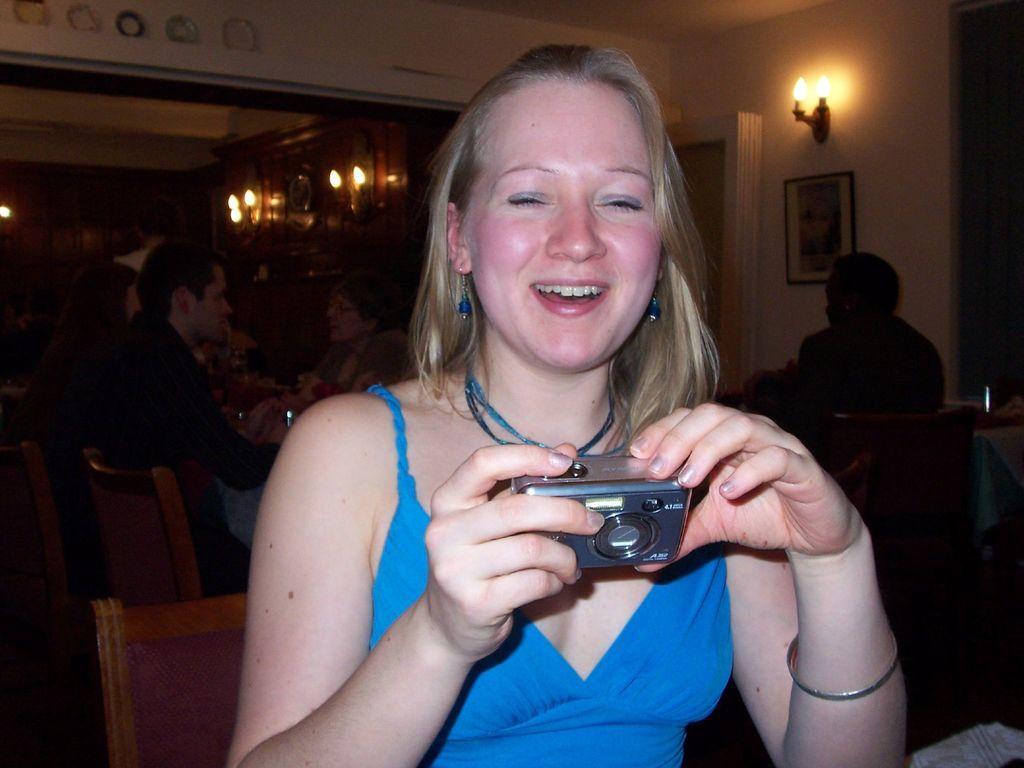Please provide a concise description of this image. In this picture we can see a woman who is holding a camera with her hands. She is smiling. On the background we can see some persons sitting on the chairs. This is the wall. And there is a frame. And these are the lights. 